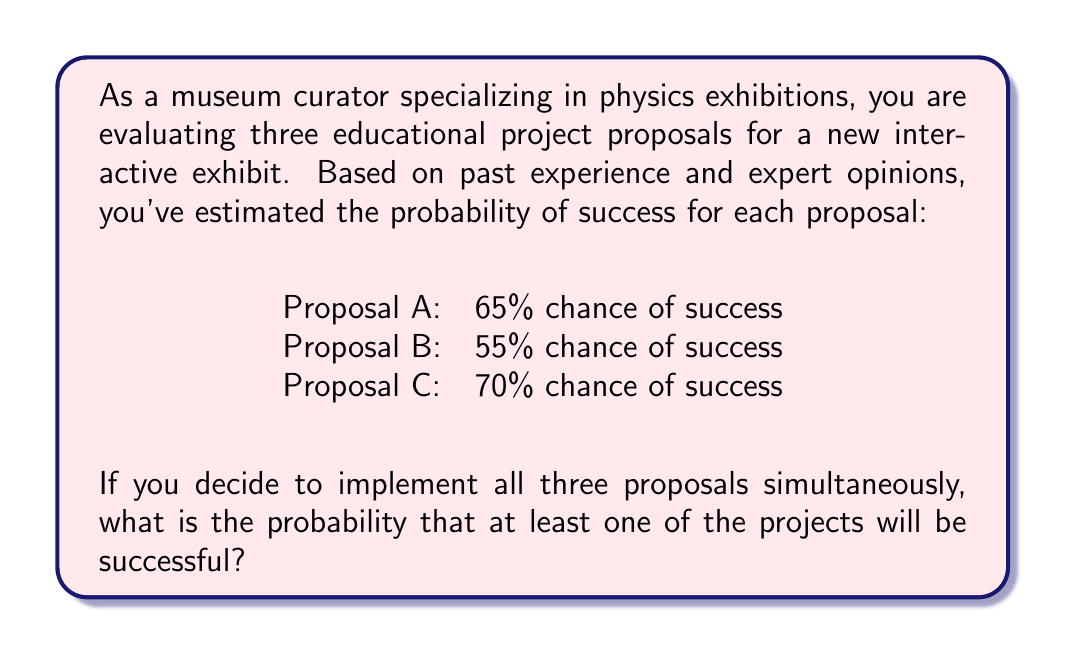Give your solution to this math problem. To solve this problem, we'll use the concept of probability of at least one event occurring, which is the complement of the probability that none of the events occur.

Let's approach this step-by-step:

1) First, we need to calculate the probability that all projects fail. We can do this by multiplying the probabilities of each project failing:

   P(all fail) = P(A fails) × P(B fails) × P(C fails)

2) The probability of each project failing is the complement of its success probability:

   P(A fails) = 1 - 0.65 = 0.35
   P(B fails) = 1 - 0.55 = 0.45
   P(C fails) = 1 - 0.70 = 0.30

3) Now, let's calculate the probability that all projects fail:

   P(all fail) = 0.35 × 0.45 × 0.30 = 0.04725

4) The probability that at least one project succeeds is the complement of the probability that all fail:

   P(at least one succeeds) = 1 - P(all fail)
                            = 1 - 0.04725
                            = 0.95275

5) Converting to a percentage:

   0.95275 × 100 = 95.275%

Therefore, the probability that at least one of the projects will be successful is approximately 95.28%.
Answer: The probability that at least one of the projects will be successful is approximately 95.28%. 